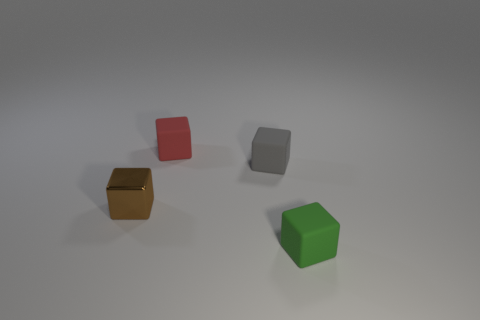Add 3 small green rubber blocks. How many objects exist? 7 Add 1 gray objects. How many gray objects exist? 2 Subtract 0 cyan blocks. How many objects are left? 4 Subtract all large red rubber spheres. Subtract all tiny red blocks. How many objects are left? 3 Add 4 metallic things. How many metallic things are left? 5 